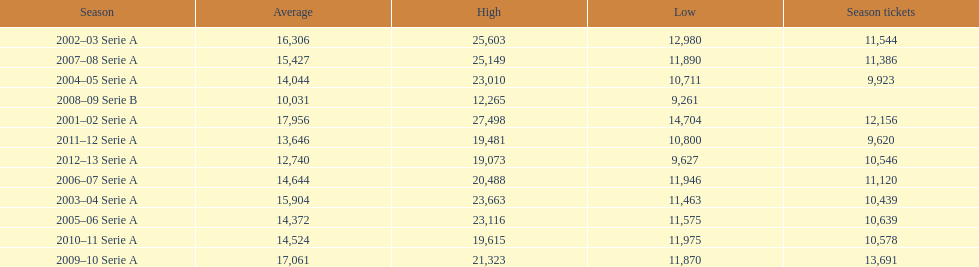What was the average attendance in 2008? 10,031. 